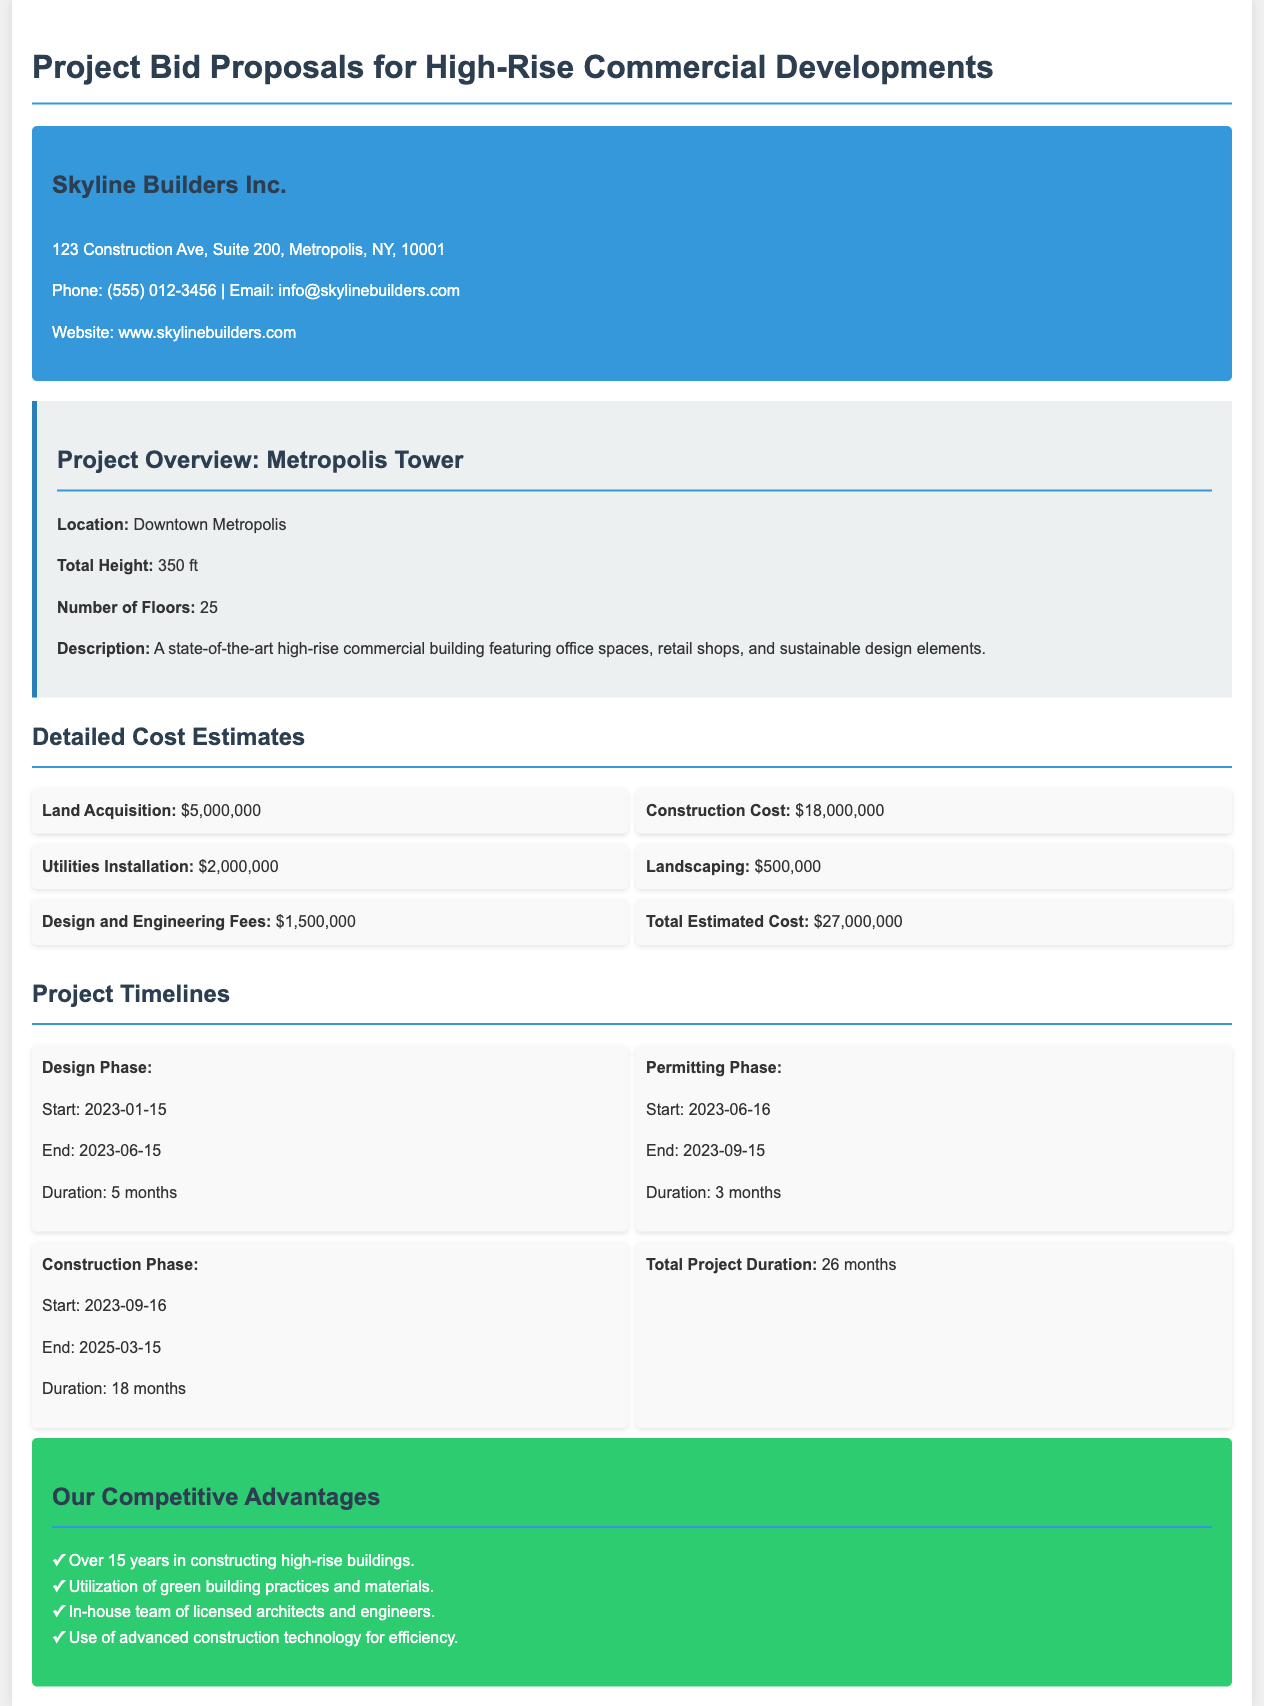What is the project name? The project name is mentioned in the project overview section of the document.
Answer: Metropolis Tower What is the location of the project? The location is specified in the project overview section.
Answer: Downtown Metropolis What is the total estimated cost? The total estimated cost is outlined in the detailed cost estimates section.
Answer: $27,000,000 How long is the construction phase? The construction phase duration is listed in the project timelines section.
Answer: 18 months When does the design phase start? The start date of the design phase is provided in the project timelines section.
Answer: 2023-01-15 What is one competitive advantage of Skyline Builders Inc.? The competitive advantages are listed in a bullet point format in the document.
Answer: Over 15 years in constructing high-rise buildings What is the total project duration? The total project duration is stated in the project timelines section.
Answer: 26 months What is the end date for the permitting phase? The end date for the permitting phase is indicated in the project timelines section.
Answer: 2023-09-15 What is included in the construction cost? The construction cost is specified in the detailed cost estimates section without needing additional details.
Answer: $18,000,000 